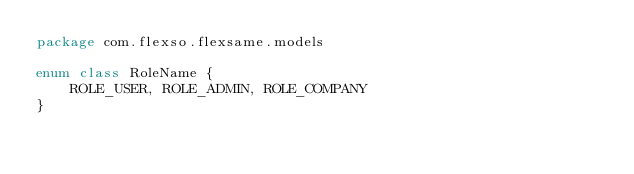<code> <loc_0><loc_0><loc_500><loc_500><_Kotlin_>package com.flexso.flexsame.models

enum class RoleName {
    ROLE_USER, ROLE_ADMIN, ROLE_COMPANY
}</code> 